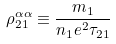<formula> <loc_0><loc_0><loc_500><loc_500>\rho _ { 2 1 } ^ { \alpha \alpha } \equiv \frac { m _ { 1 } } { n _ { 1 } e ^ { 2 } \tau _ { 2 1 } }</formula> 